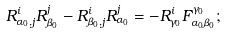Convert formula to latex. <formula><loc_0><loc_0><loc_500><loc_500>R _ { \alpha _ { 0 } , j } ^ { i } R _ { \beta _ { 0 } } ^ { j } - R _ { \beta _ { 0 } , j } ^ { i } R _ { \alpha _ { 0 } } ^ { j } = - R _ { \gamma _ { 0 } } ^ { i } F _ { \alpha _ { 0 } \beta _ { 0 } } ^ { \gamma _ { 0 } } ;</formula> 